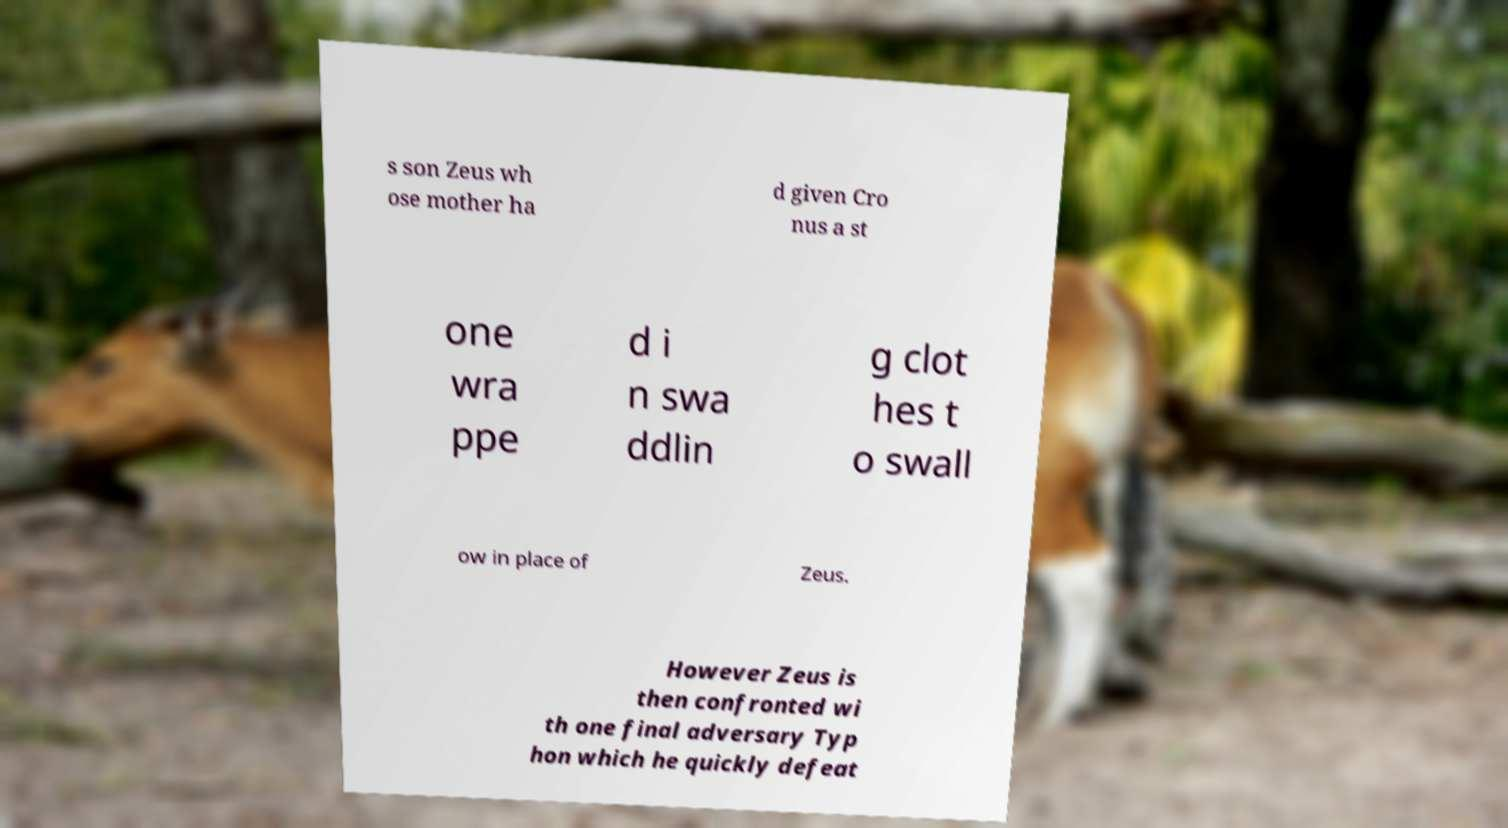What messages or text are displayed in this image? I need them in a readable, typed format. s son Zeus wh ose mother ha d given Cro nus a st one wra ppe d i n swa ddlin g clot hes t o swall ow in place of Zeus. However Zeus is then confronted wi th one final adversary Typ hon which he quickly defeat 